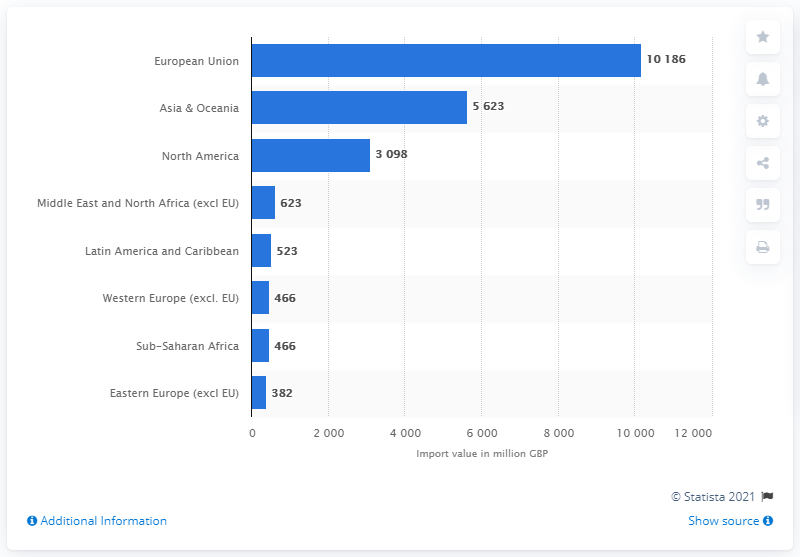Mention a couple of crucial points in this snapshot. In 2018, Scotland imported a total of 5,623 pounds of goods from Asia and Oceanic countries. 